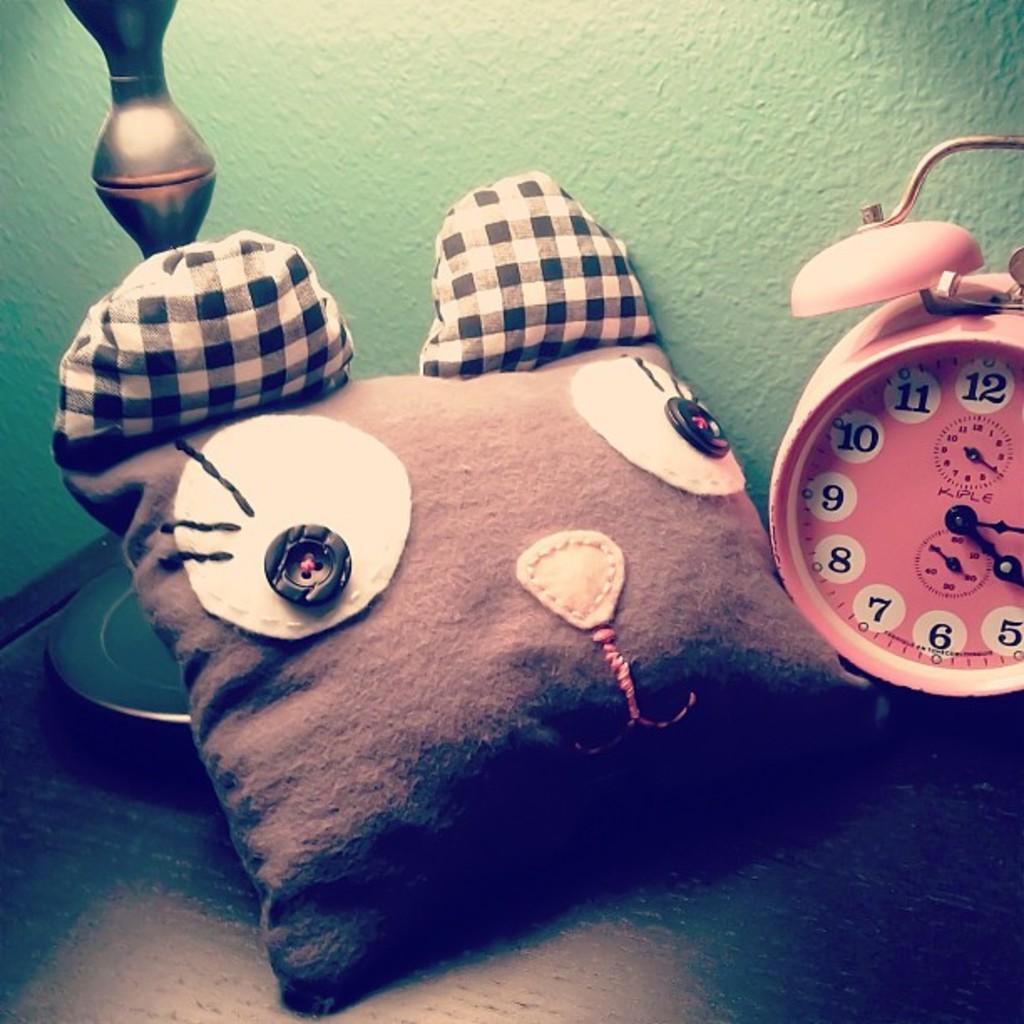<image>
Offer a succinct explanation of the picture presented. A cat pillow and a pink Kiple alarm clock are on a table. 